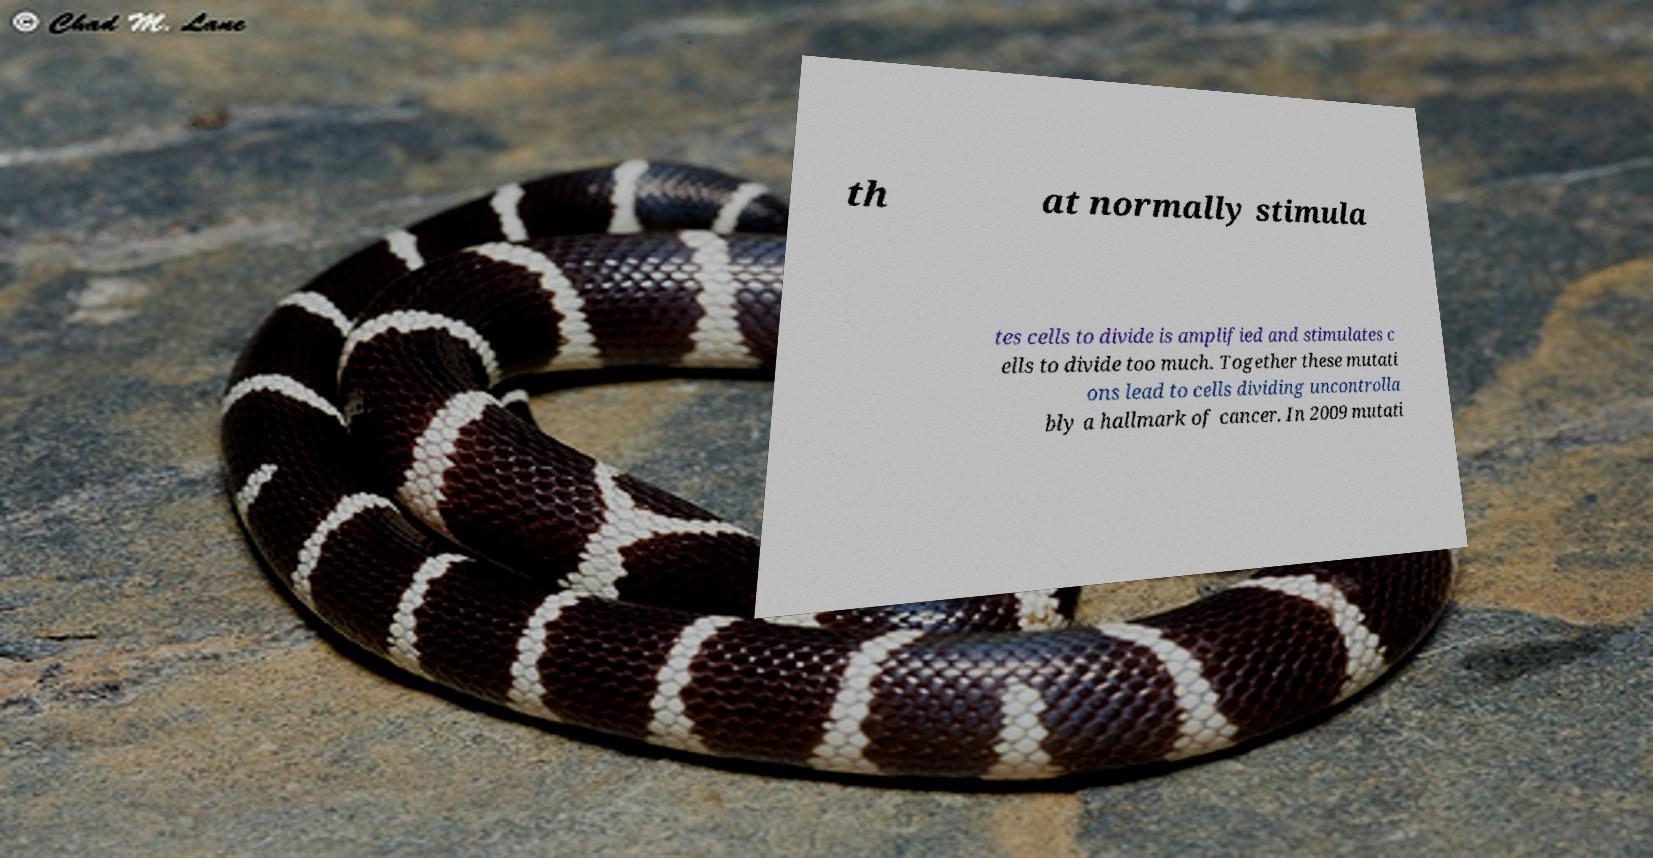Please identify and transcribe the text found in this image. th at normally stimula tes cells to divide is amplified and stimulates c ells to divide too much. Together these mutati ons lead to cells dividing uncontrolla bly a hallmark of cancer. In 2009 mutati 